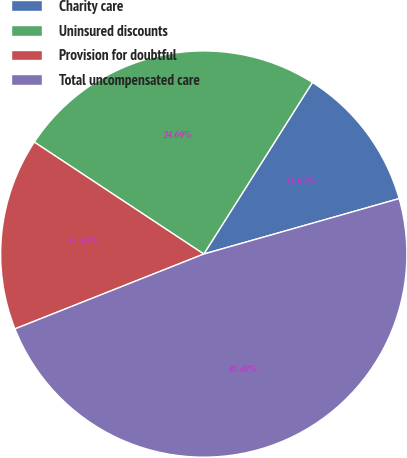Convert chart. <chart><loc_0><loc_0><loc_500><loc_500><pie_chart><fcel>Charity care<fcel>Uninsured discounts<fcel>Provision for doubtful<fcel>Total uncompensated care<nl><fcel>11.62%<fcel>24.69%<fcel>15.3%<fcel>48.4%<nl></chart> 